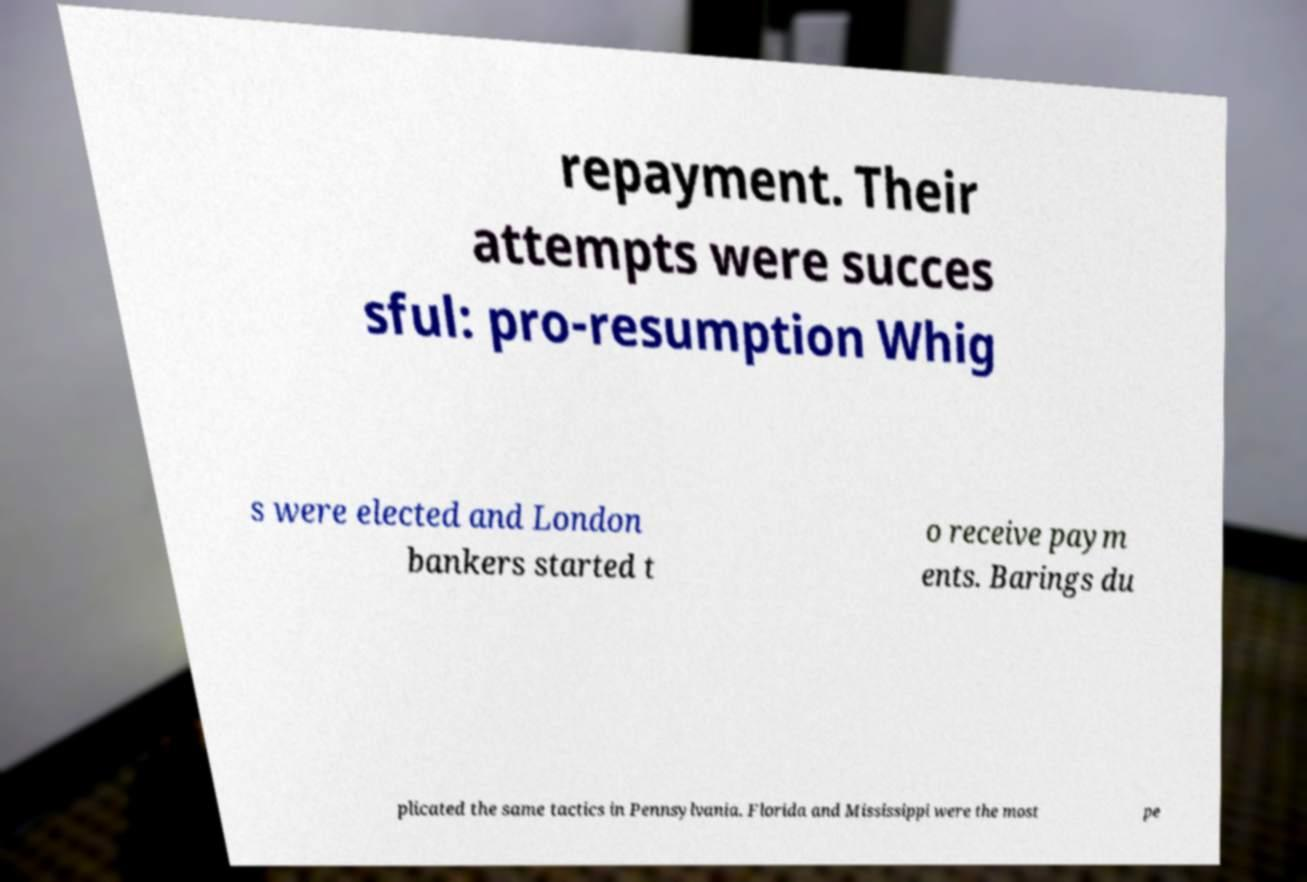Can you accurately transcribe the text from the provided image for me? repayment. Their attempts were succes sful: pro-resumption Whig s were elected and London bankers started t o receive paym ents. Barings du plicated the same tactics in Pennsylvania. Florida and Mississippi were the most pe 